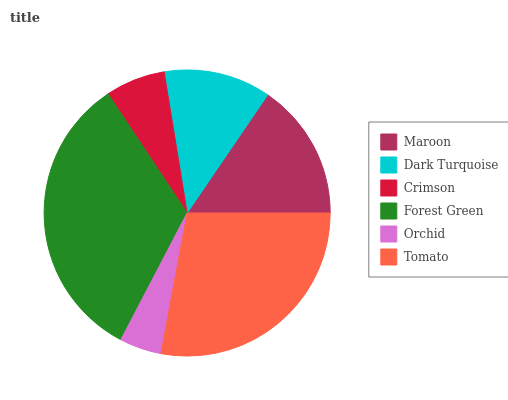Is Orchid the minimum?
Answer yes or no. Yes. Is Forest Green the maximum?
Answer yes or no. Yes. Is Dark Turquoise the minimum?
Answer yes or no. No. Is Dark Turquoise the maximum?
Answer yes or no. No. Is Maroon greater than Dark Turquoise?
Answer yes or no. Yes. Is Dark Turquoise less than Maroon?
Answer yes or no. Yes. Is Dark Turquoise greater than Maroon?
Answer yes or no. No. Is Maroon less than Dark Turquoise?
Answer yes or no. No. Is Maroon the high median?
Answer yes or no. Yes. Is Dark Turquoise the low median?
Answer yes or no. Yes. Is Forest Green the high median?
Answer yes or no. No. Is Crimson the low median?
Answer yes or no. No. 